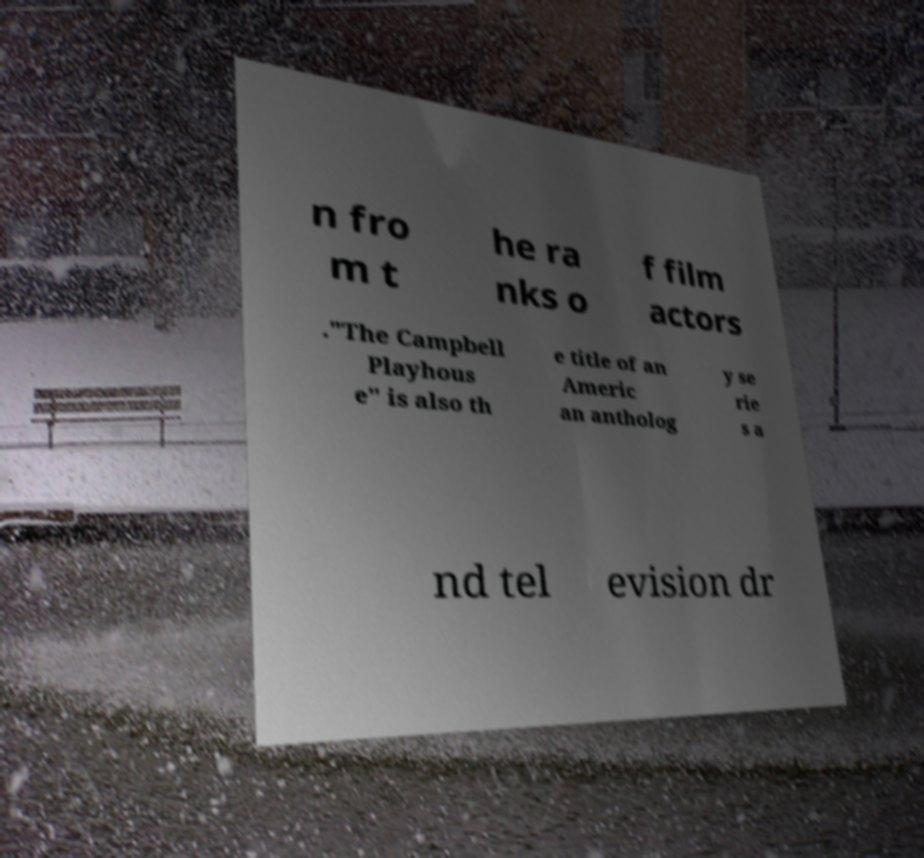Please read and relay the text visible in this image. What does it say? n fro m t he ra nks o f film actors ."The Campbell Playhous e" is also th e title of an Americ an antholog y se rie s a nd tel evision dr 